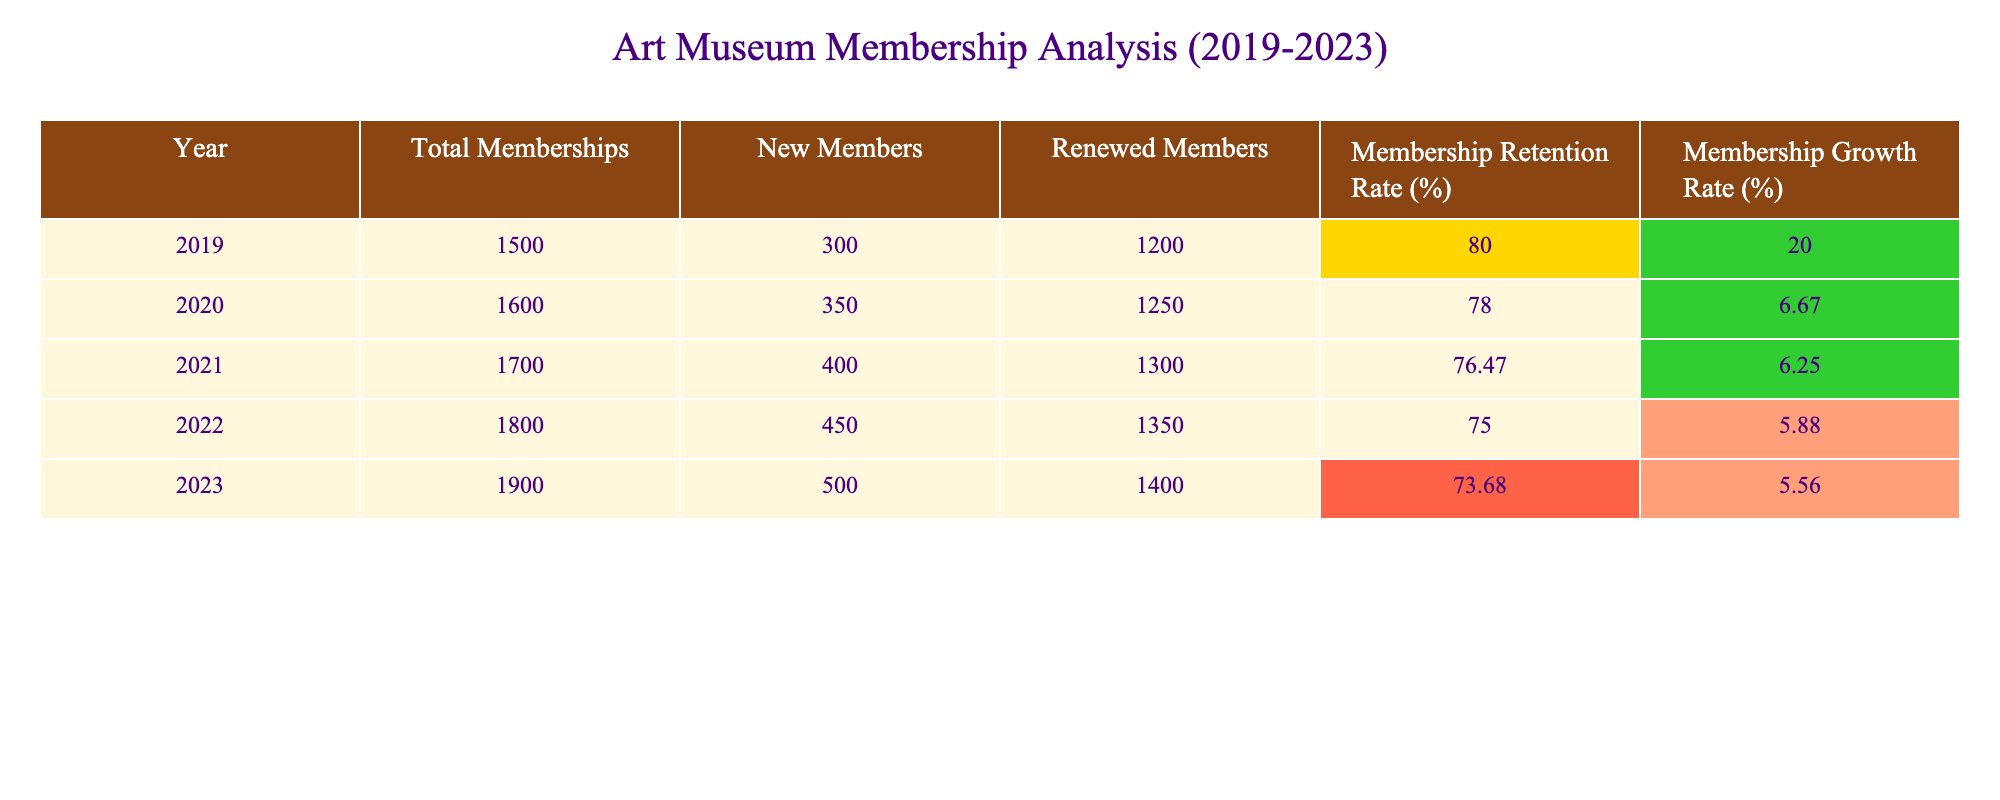What was the total number of memberships in 2021? Referring to the table, the total memberships for the year 2021 is clearly listed as 1700.
Answer: 1700 What was the membership retention rate in 2023? The table indicates that the membership retention rate for 2023 is 73.68%.
Answer: 73.68% How many new members joined in 2022? According to the table, the number of new members in 2022 is stated as 450.
Answer: 450 What is the difference in total memberships between 2019 and 2023? In 2019, the total memberships were 1500, and in 2023, they were 1900. The difference is calculated as 1900 - 1500 = 400.
Answer: 400 What was the average membership growth rate over these five years? The growth rates from 2019 to 2023 are 20, 6.67, 6.25, 5.88, and 5.56. The sum of these rates is 44.36, and dividing by 5 gives an average of 44.36 / 5 = 8.872.
Answer: 8.872 Is the membership retention rate consistently above 75% during the analyzed period? The retention rates were 80% (2019), 78% (2020), 76.47% (2021), 75% (2022), and 73.68% (2023). Since the rates fell below 75% in the last two years, the answer is no.
Answer: No In which year did the membership growth rate first fall below 6%? Analyzing the growth rates, 20% (2019), 6.67% (2020), 6.25% (2021), 5.88% (2022), and 5.56% (2023), it is clear that 2022 was the first year the growth rate fell below 6%.
Answer: 2022 What is the trend of the membership retention rate over the five years? The retention rates have decreased from 80% in 2019 to 73.68% in 2023. This indicates a downward trend over the analyzed period.
Answer: Downward trend How many total members were renewed in 2020? The table states that in 2020, the number of renewed members was 1250.
Answer: 1250 If we consider the years with a growth rate greater than 6%, in how many years did this occur? The years with growth rates greater than 6% were 2019 (20%) and 2020 (6.67%), totaling 2 years.
Answer: 2 